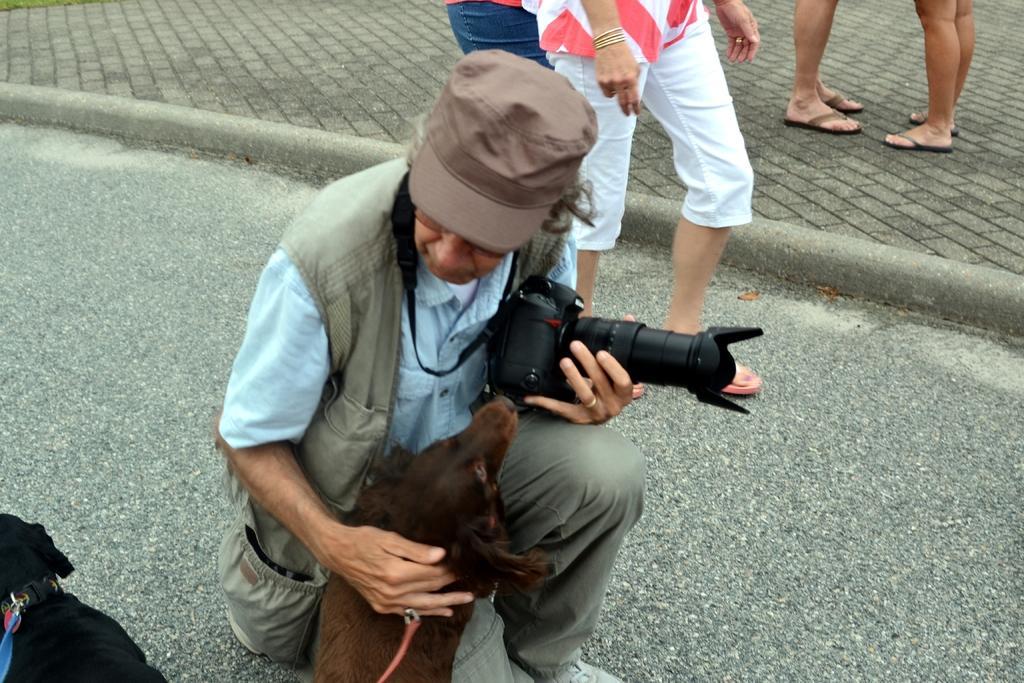Could you give a brief overview of what you see in this image? In this picture we can find a man sitting and holding a dog in one hand and camera in other hand. He is wearing a cap, just beside to that man, we can find another persons walking and standing. 